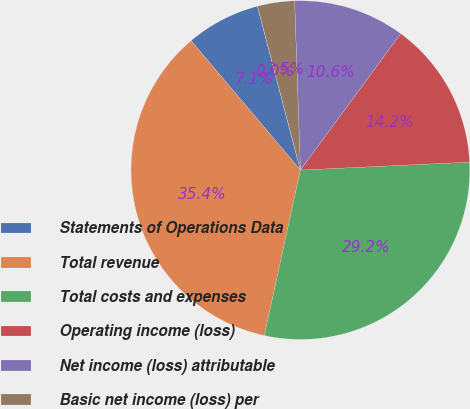<chart> <loc_0><loc_0><loc_500><loc_500><pie_chart><fcel>Statements of Operations Data<fcel>Total revenue<fcel>Total costs and expenses<fcel>Operating income (loss)<fcel>Net income (loss) attributable<fcel>Basic net income (loss) per<fcel>Diluted net income (loss) per<nl><fcel>7.08%<fcel>35.42%<fcel>29.15%<fcel>14.17%<fcel>10.63%<fcel>3.54%<fcel>0.0%<nl></chart> 